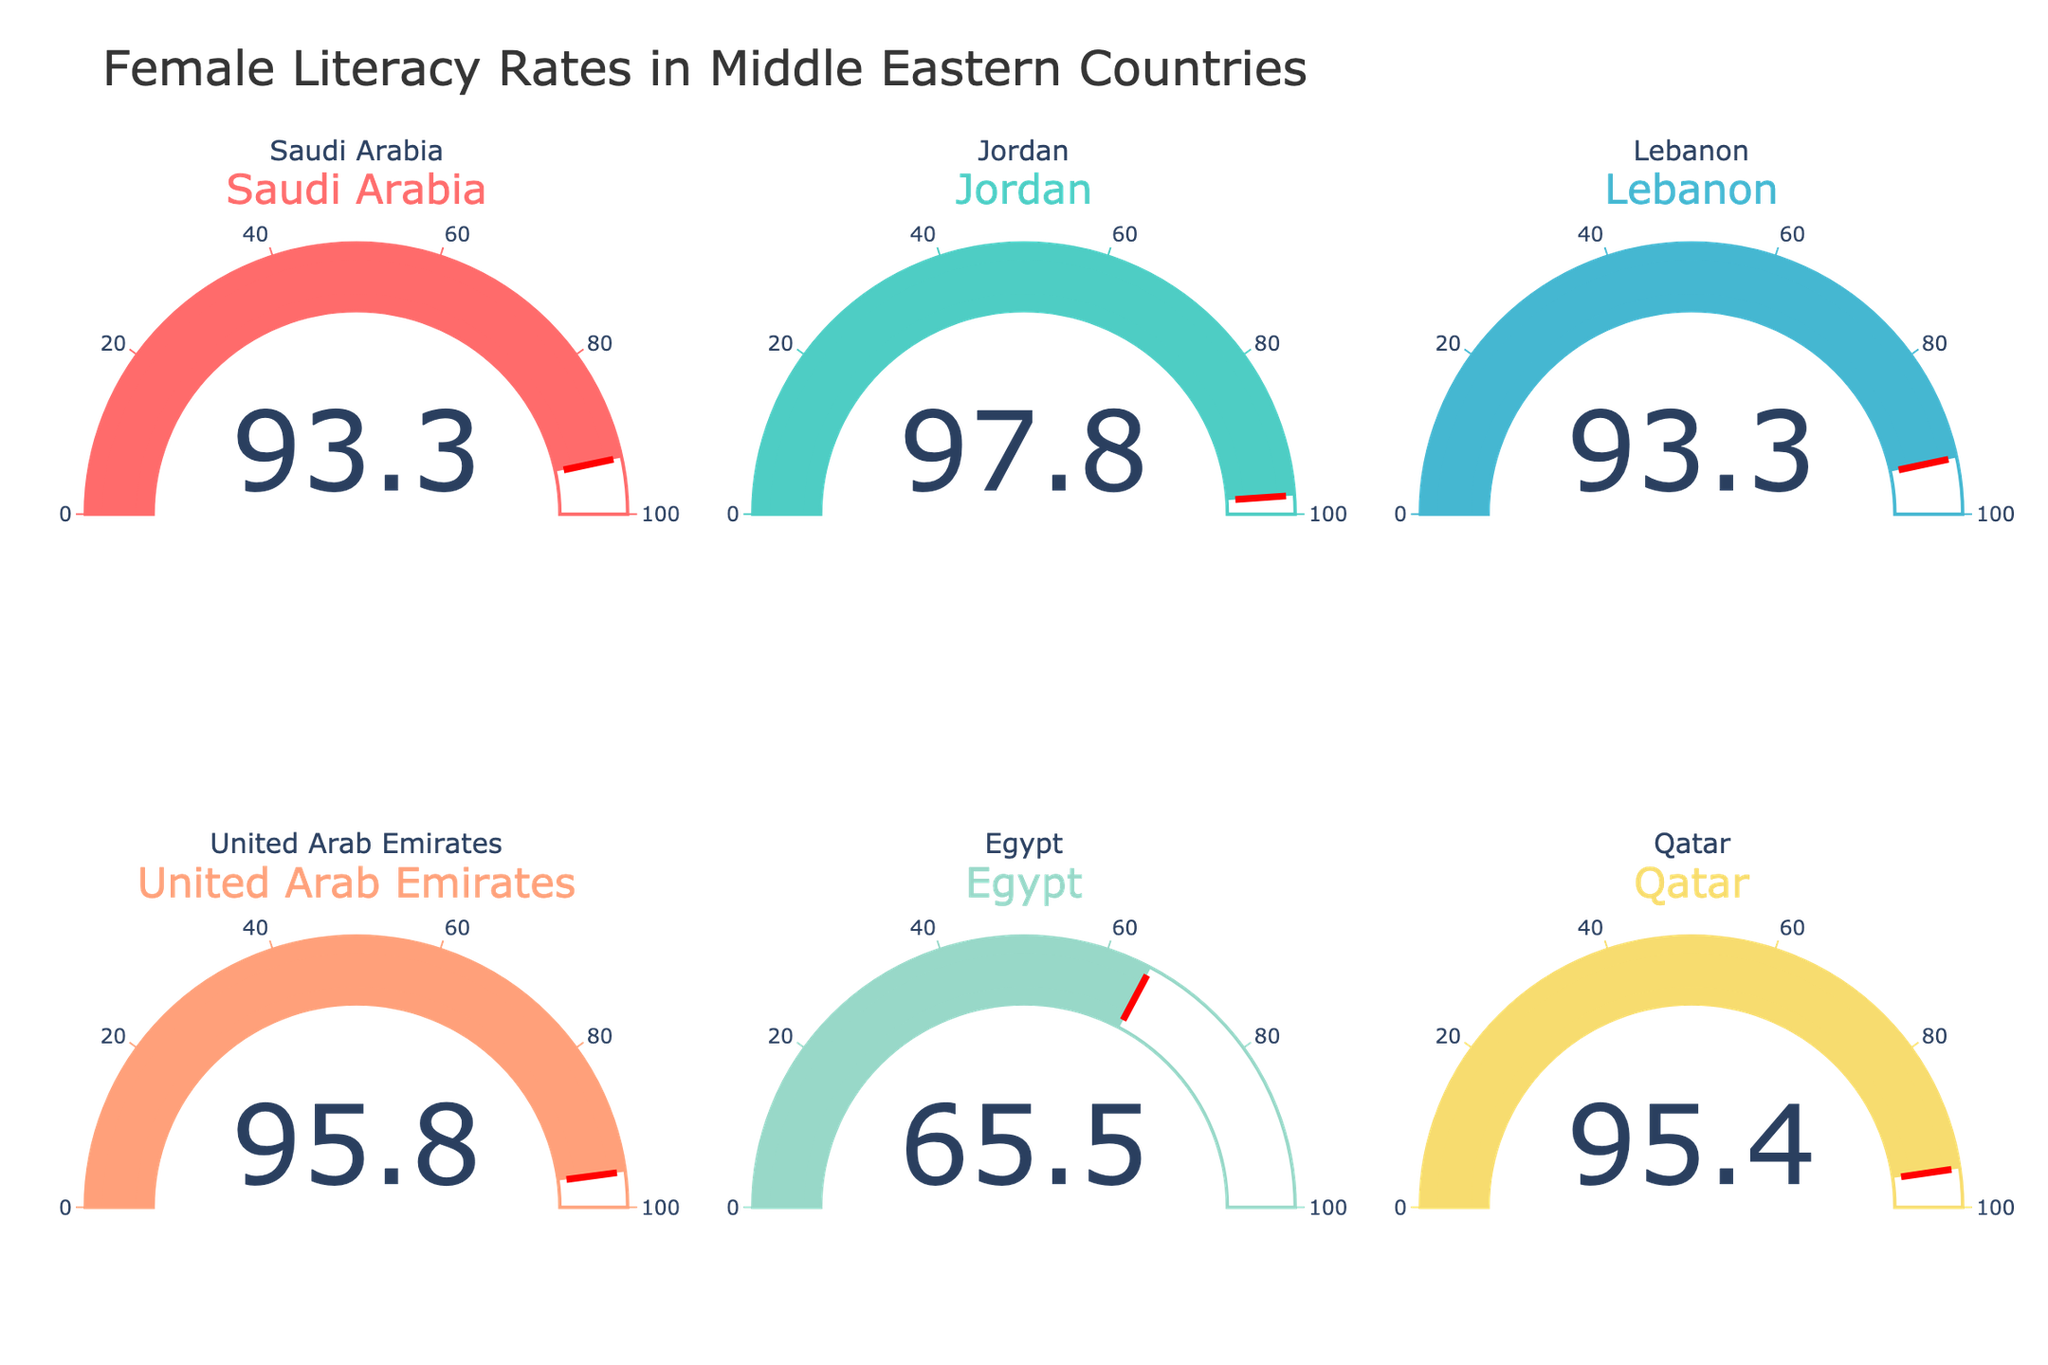What is the female literacy rate in Saudi Arabia? The gauge chart for Saudi Arabia shows a value denoted in percentage representing the female literacy rate.
Answer: 93.3% Which country has the highest female literacy rate? By comparing all the values displayed on the gauge charts, the highest literacy rate percentage shown is under Jordan.
Answer: Jordan How much higher is Jordan's female literacy rate compared to Egypt? Jordan's female literacy rate is 97.8% and Egypt's is 65.5%. To find the difference, subtract Egypt's rate from Jordan's rate: 97.8% - 65.5%.
Answer: 32.3% Is Lebanon’s female literacy rate equal to that of Saudi Arabia? The gauge chart for Lebanon shows a rate of 93.3%, and likewise, the chart for Saudi Arabia shows 93.3%.
Answer: Yes What is the average female literacy rate among Qatar, the UAE, and Saudi Arabia? Adding the literacy rates: Qatar (95.4%), the UAE (95.8%), and Saudi Arabia (93.3%), we get 95.4 + 95.8 + 93.3 = 284.5. Dividing by 3 gives the average (284.5/3).
Answer: 94.83% Which two countries have the closest female literacy rates? Comparing the gauge values, Lebanon and Saudi Arabia both have 93.3%, making them the closest.
Answer: Lebanon and Saudi Arabia How does the female literacy rate of the UAE compare with Qatar? The UAE has a literacy rate of 95.8% while Qatar is at 95.4%. Subtracting Qatar's rate from the UAE's: 95.8% - 95.4%.
Answer: 0.4% higher Is Egypt's female literacy rate greater than 70%? The gauge chart for Egypt shows a literacy rate of 65.5%, which is less than 70%.
Answer: No 